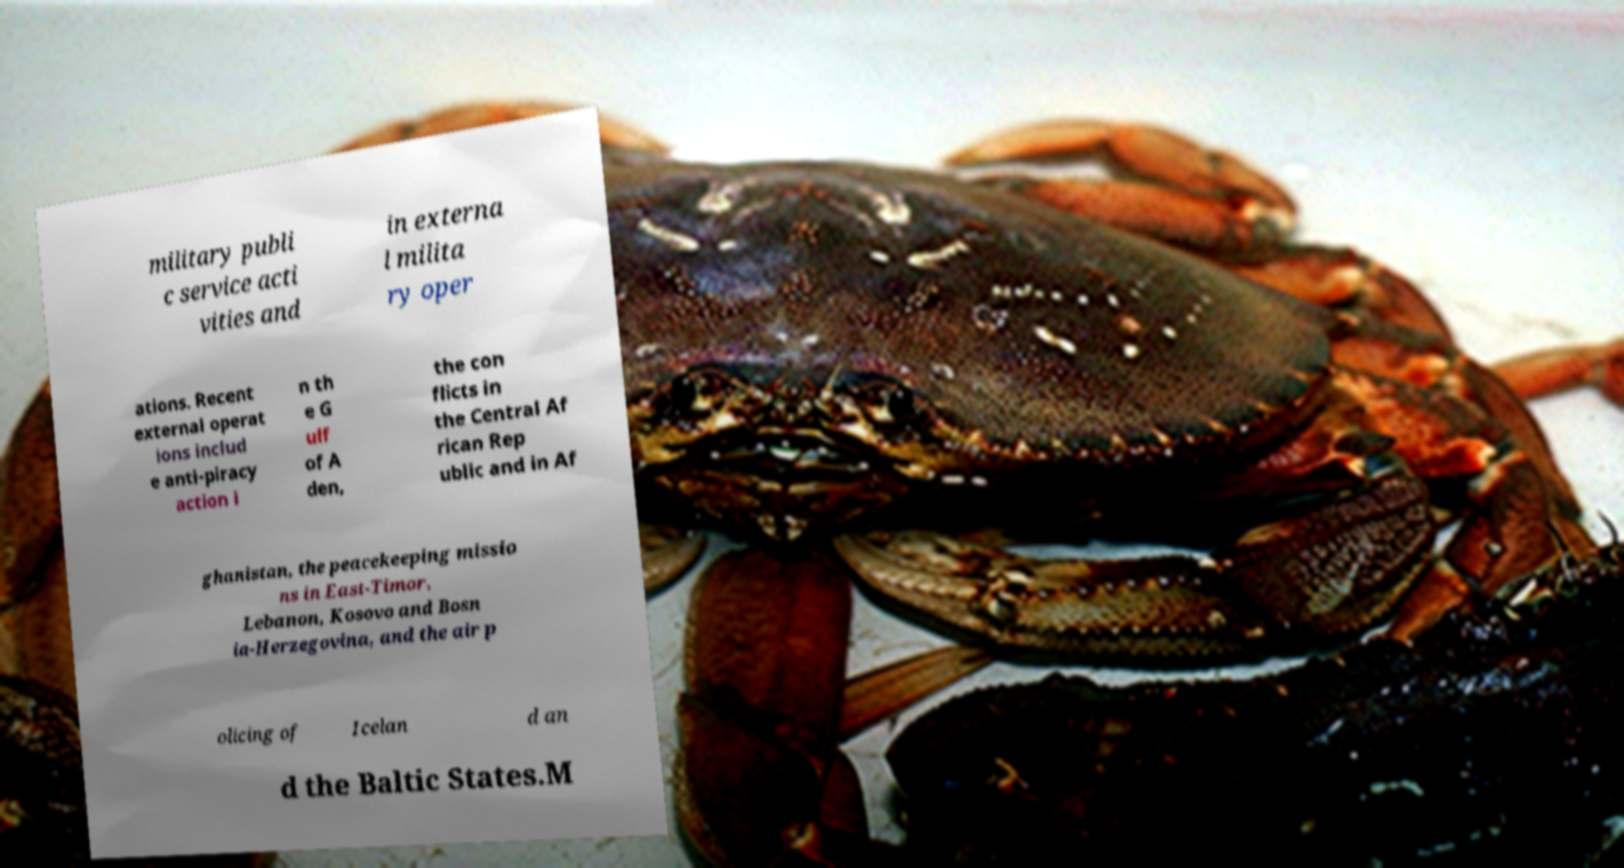Could you assist in decoding the text presented in this image and type it out clearly? military publi c service acti vities and in externa l milita ry oper ations. Recent external operat ions includ e anti-piracy action i n th e G ulf of A den, the con flicts in the Central Af rican Rep ublic and in Af ghanistan, the peacekeeping missio ns in East-Timor, Lebanon, Kosovo and Bosn ia-Herzegovina, and the air p olicing of Icelan d an d the Baltic States.M 